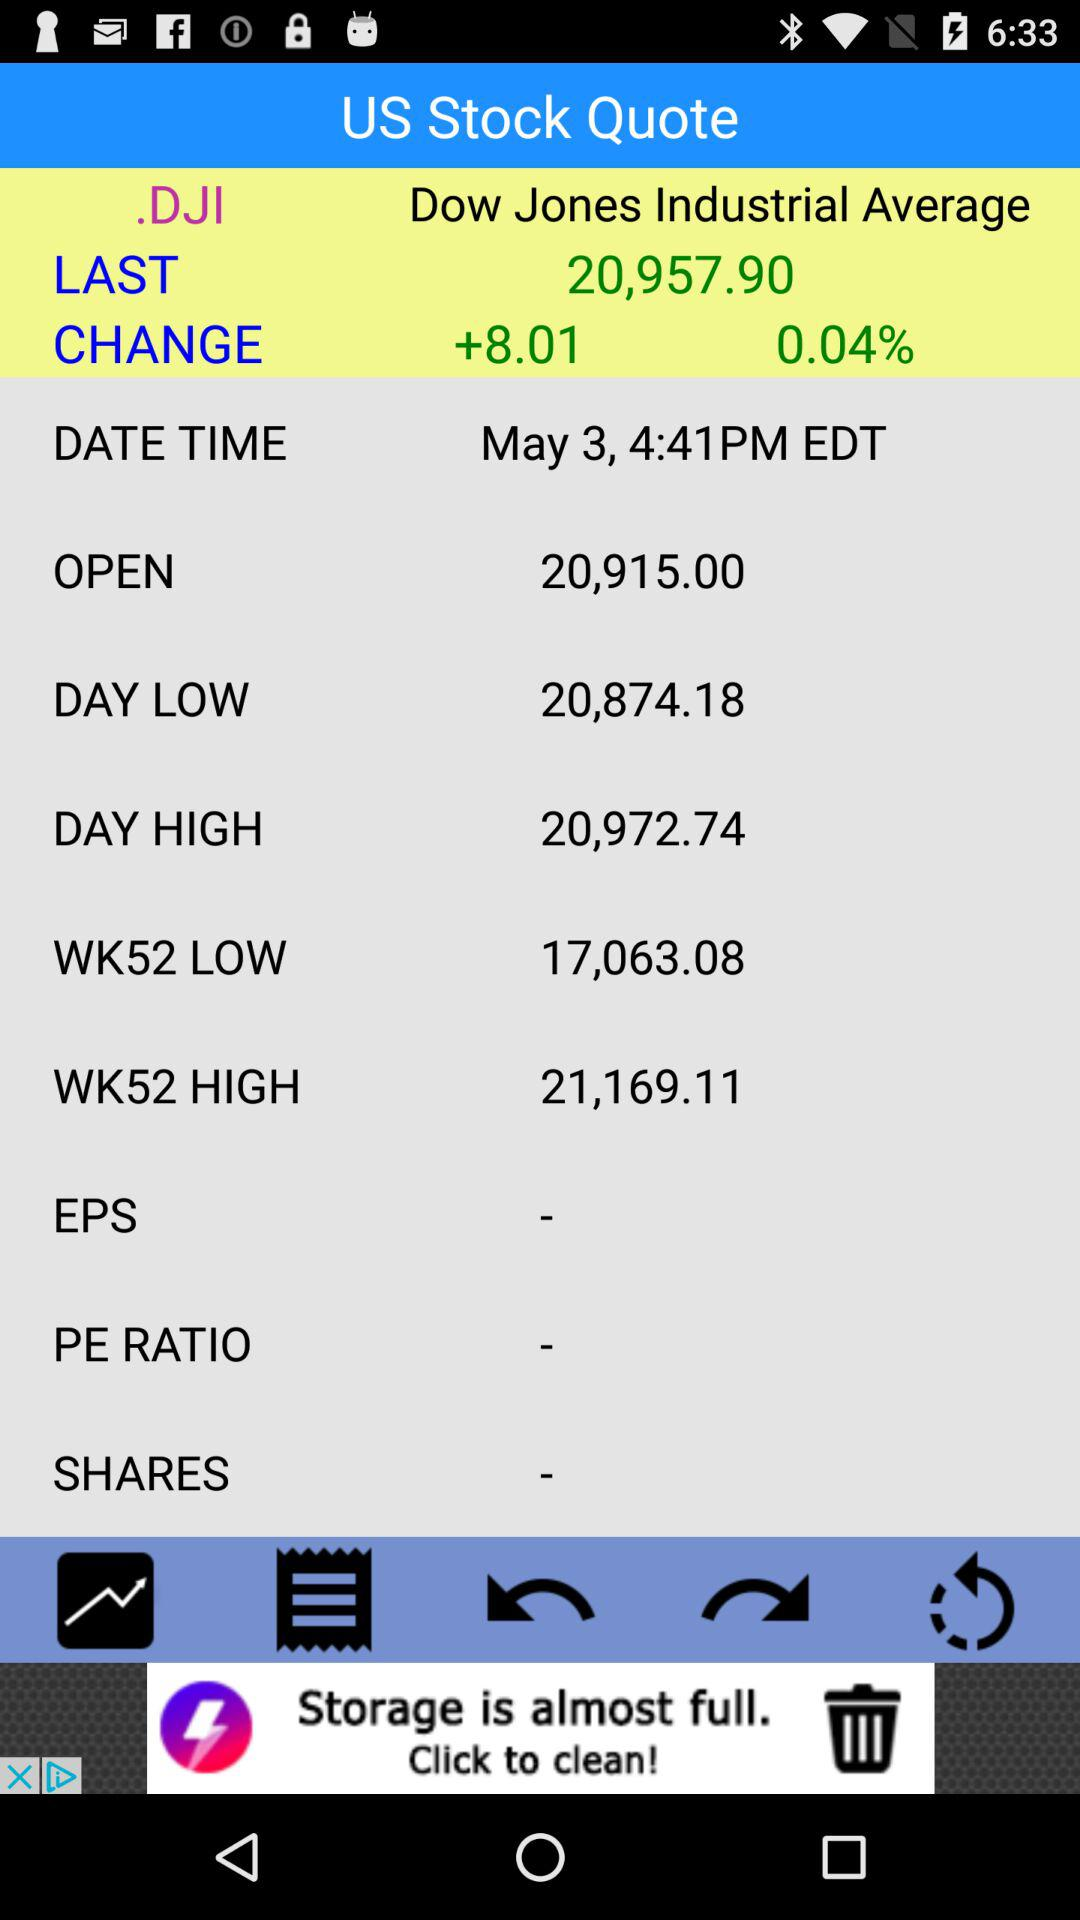What is the opening price? The opening price is 20,915.00. 